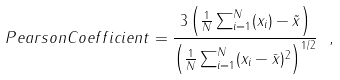Convert formula to latex. <formula><loc_0><loc_0><loc_500><loc_500>P e a r s o n C o e f f i c i e n t = \frac { 3 \left ( \frac { 1 } { N } \sum ^ { N } _ { i = 1 } ( x _ { i } ) - \tilde { x } \right ) } { \left ( \frac { 1 } { N } \sum ^ { N } _ { i = 1 } ( x _ { i } - \bar { x } ) ^ { 2 } \right ) ^ { 1 / 2 } } \ { , }</formula> 